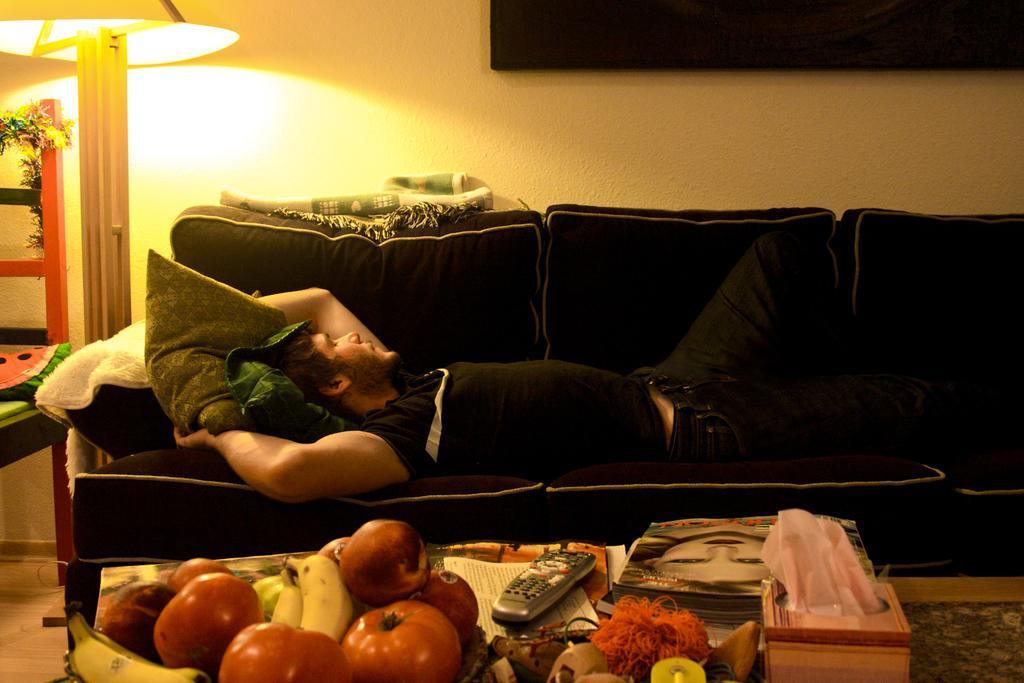Describe this image in one or two sentences. Here in this picture we can see a man lying on a sofa and in the front we can see a table, on which we can see some fruits and vegetables present and we can also see a remote and some magazines present on it and we can also see tissue box present and on the left side we can see a lamp present and we can see cushions present on the sofa. 